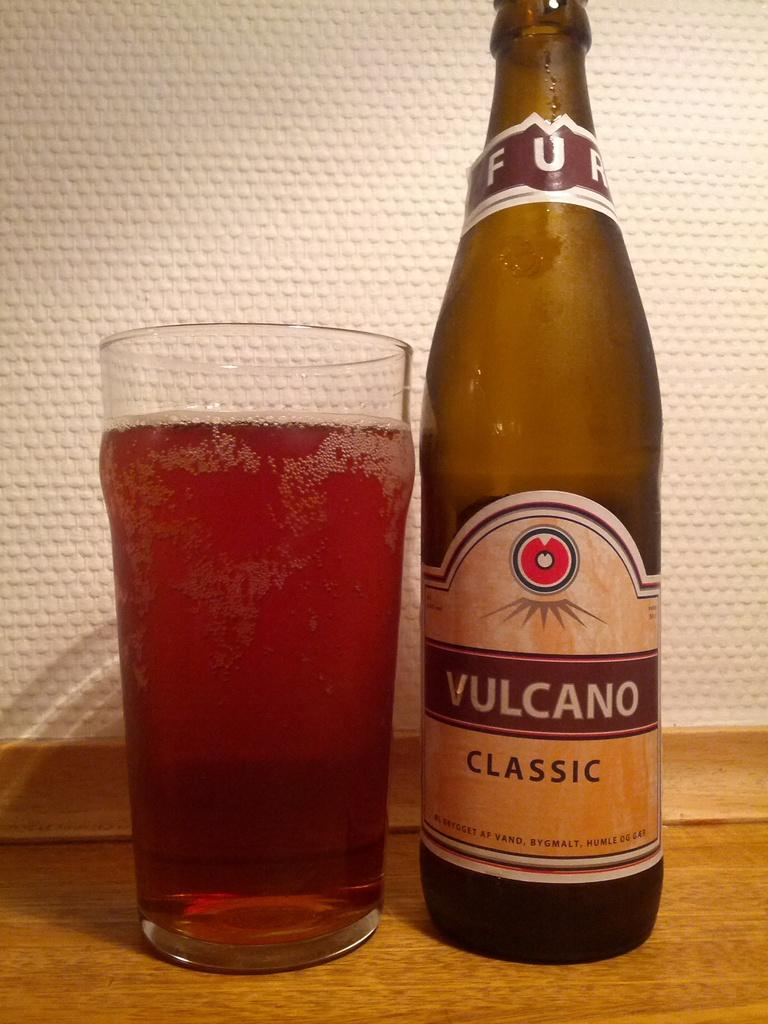<image>
Present a compact description of the photo's key features. A glass bottle of Vulcano Classic and a full pint glass to the left of it. 